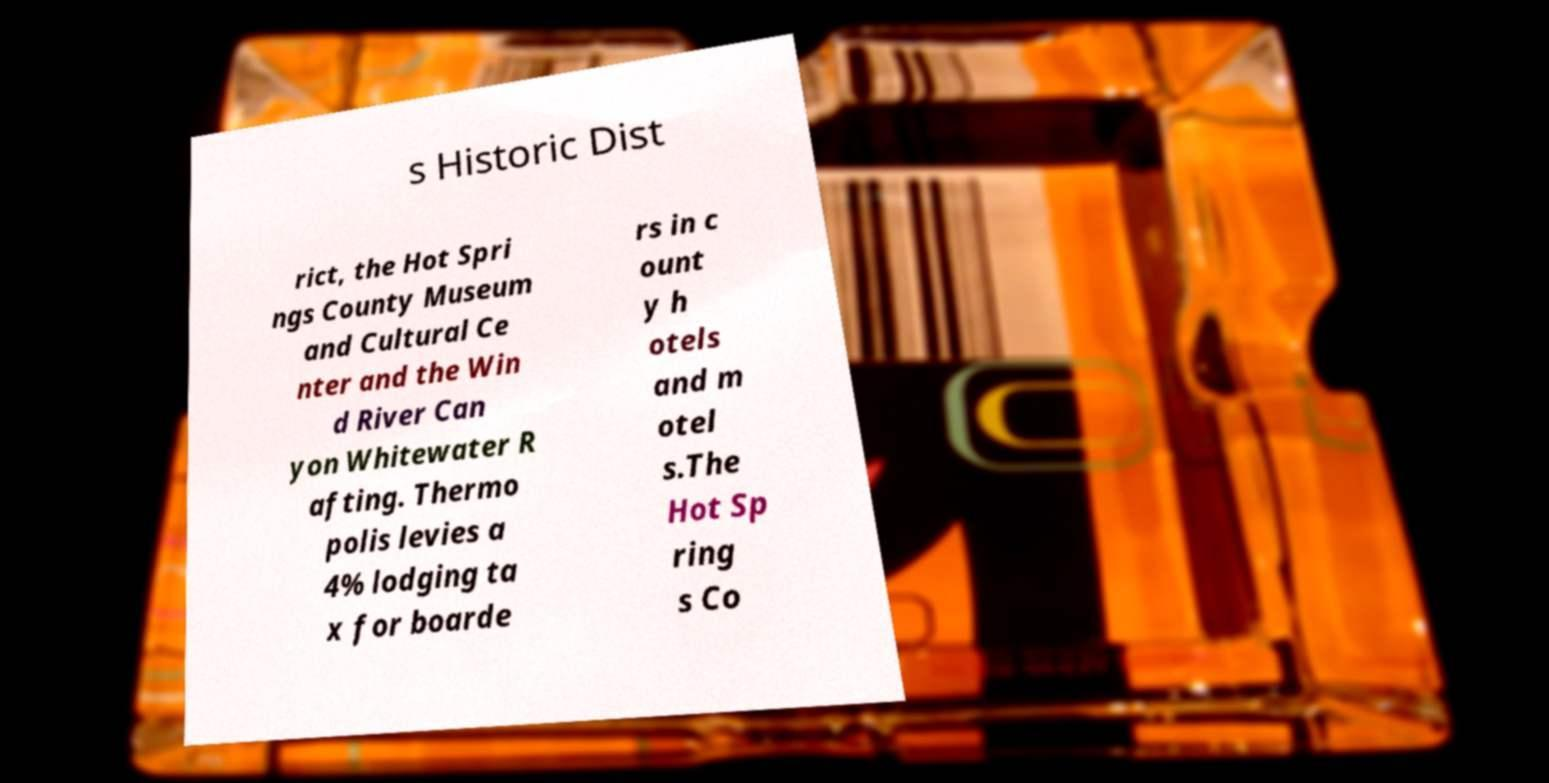There's text embedded in this image that I need extracted. Can you transcribe it verbatim? s Historic Dist rict, the Hot Spri ngs County Museum and Cultural Ce nter and the Win d River Can yon Whitewater R afting. Thermo polis levies a 4% lodging ta x for boarde rs in c ount y h otels and m otel s.The Hot Sp ring s Co 